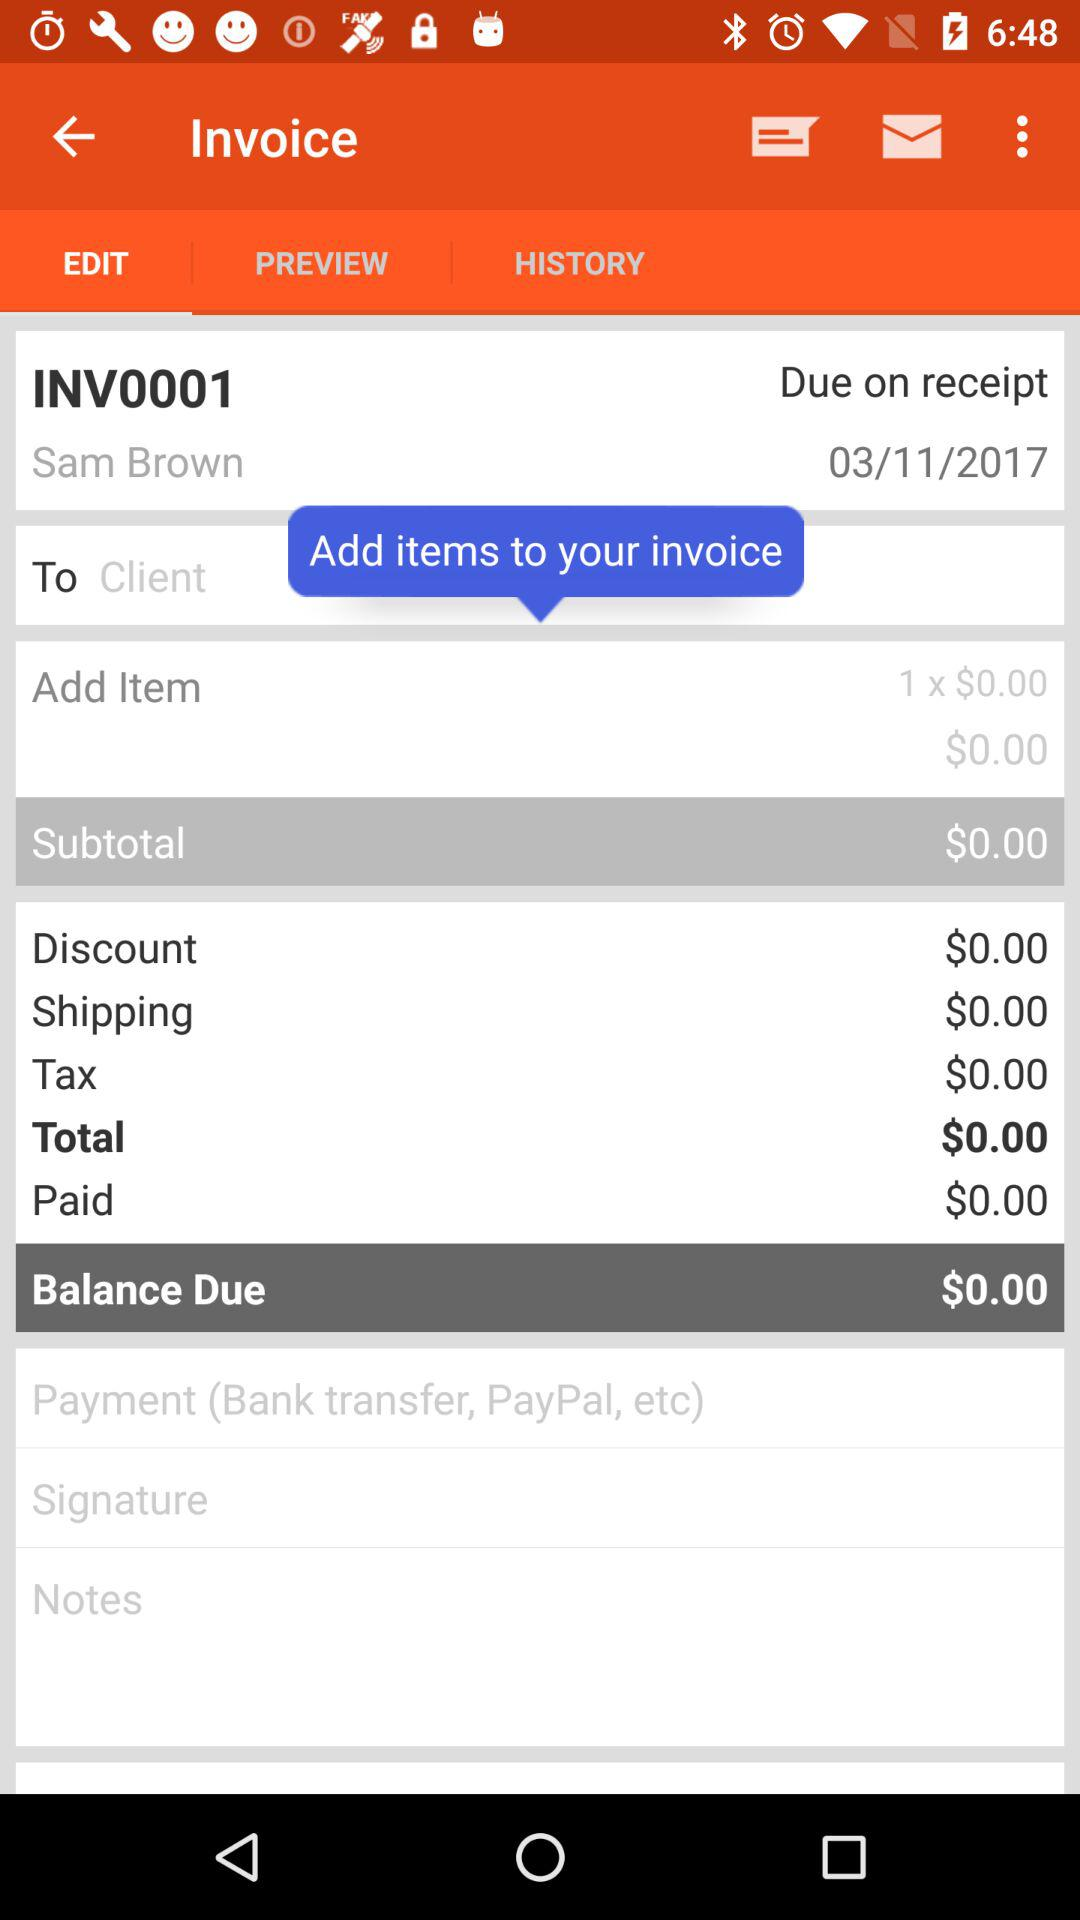How much balance is due? The due balance is $0.00. 